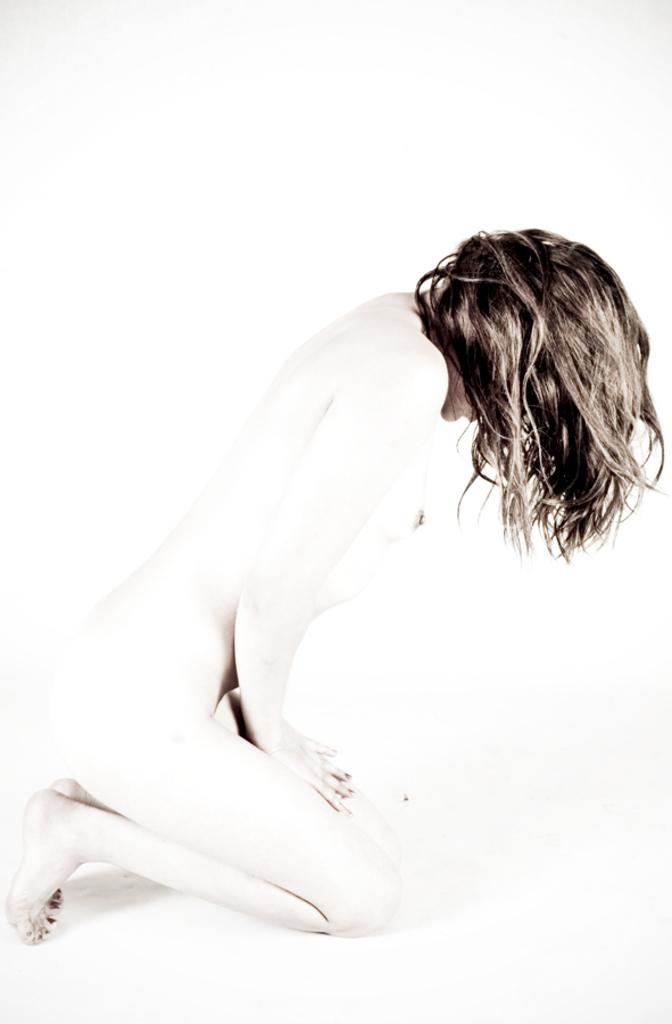What is the main subject of the image? The image contains a picture of a woman. What color is the background of the image? The background of the image is white. How many locks are visible on the woman's head in the image? There are no locks visible on the woman's head in the image, as locks typically refer to hair and the image does not show any hair. 